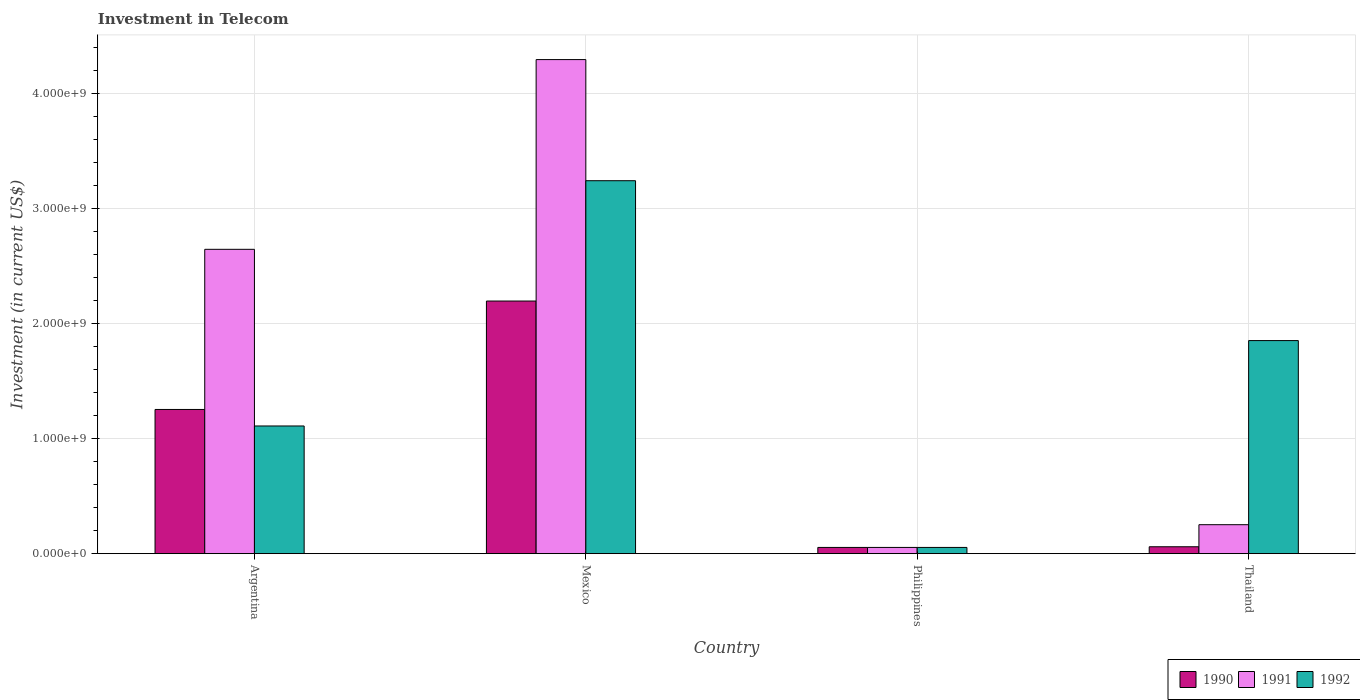How many groups of bars are there?
Ensure brevity in your answer.  4. Are the number of bars on each tick of the X-axis equal?
Provide a short and direct response. Yes. How many bars are there on the 1st tick from the left?
Your answer should be compact. 3. How many bars are there on the 2nd tick from the right?
Provide a short and direct response. 3. What is the amount invested in telecom in 1992 in Thailand?
Ensure brevity in your answer.  1.85e+09. Across all countries, what is the maximum amount invested in telecom in 1992?
Ensure brevity in your answer.  3.24e+09. Across all countries, what is the minimum amount invested in telecom in 1990?
Give a very brief answer. 5.42e+07. In which country was the amount invested in telecom in 1991 minimum?
Give a very brief answer. Philippines. What is the total amount invested in telecom in 1992 in the graph?
Offer a terse response. 6.26e+09. What is the difference between the amount invested in telecom in 1990 in Mexico and that in Thailand?
Provide a short and direct response. 2.14e+09. What is the difference between the amount invested in telecom in 1991 in Argentina and the amount invested in telecom in 1990 in Philippines?
Provide a short and direct response. 2.59e+09. What is the average amount invested in telecom in 1991 per country?
Offer a very short reply. 1.81e+09. What is the difference between the amount invested in telecom of/in 1990 and amount invested in telecom of/in 1991 in Mexico?
Make the answer very short. -2.10e+09. What is the ratio of the amount invested in telecom in 1992 in Mexico to that in Thailand?
Make the answer very short. 1.75. Is the amount invested in telecom in 1992 in Mexico less than that in Thailand?
Offer a very short reply. No. What is the difference between the highest and the second highest amount invested in telecom in 1991?
Provide a short and direct response. 1.65e+09. What is the difference between the highest and the lowest amount invested in telecom in 1991?
Make the answer very short. 4.24e+09. What does the 1st bar from the right in Argentina represents?
Your answer should be very brief. 1992. How many countries are there in the graph?
Provide a succinct answer. 4. What is the difference between two consecutive major ticks on the Y-axis?
Ensure brevity in your answer.  1.00e+09. Are the values on the major ticks of Y-axis written in scientific E-notation?
Offer a terse response. Yes. Does the graph contain grids?
Provide a short and direct response. Yes. How are the legend labels stacked?
Your response must be concise. Horizontal. What is the title of the graph?
Ensure brevity in your answer.  Investment in Telecom. Does "2013" appear as one of the legend labels in the graph?
Offer a terse response. No. What is the label or title of the X-axis?
Make the answer very short. Country. What is the label or title of the Y-axis?
Give a very brief answer. Investment (in current US$). What is the Investment (in current US$) of 1990 in Argentina?
Provide a short and direct response. 1.25e+09. What is the Investment (in current US$) in 1991 in Argentina?
Your response must be concise. 2.65e+09. What is the Investment (in current US$) of 1992 in Argentina?
Provide a succinct answer. 1.11e+09. What is the Investment (in current US$) of 1990 in Mexico?
Ensure brevity in your answer.  2.20e+09. What is the Investment (in current US$) in 1991 in Mexico?
Provide a short and direct response. 4.30e+09. What is the Investment (in current US$) of 1992 in Mexico?
Offer a very short reply. 3.24e+09. What is the Investment (in current US$) of 1990 in Philippines?
Make the answer very short. 5.42e+07. What is the Investment (in current US$) of 1991 in Philippines?
Give a very brief answer. 5.42e+07. What is the Investment (in current US$) of 1992 in Philippines?
Ensure brevity in your answer.  5.42e+07. What is the Investment (in current US$) in 1990 in Thailand?
Provide a short and direct response. 6.00e+07. What is the Investment (in current US$) in 1991 in Thailand?
Give a very brief answer. 2.52e+08. What is the Investment (in current US$) of 1992 in Thailand?
Ensure brevity in your answer.  1.85e+09. Across all countries, what is the maximum Investment (in current US$) in 1990?
Provide a succinct answer. 2.20e+09. Across all countries, what is the maximum Investment (in current US$) in 1991?
Provide a short and direct response. 4.30e+09. Across all countries, what is the maximum Investment (in current US$) of 1992?
Your answer should be compact. 3.24e+09. Across all countries, what is the minimum Investment (in current US$) in 1990?
Keep it short and to the point. 5.42e+07. Across all countries, what is the minimum Investment (in current US$) of 1991?
Make the answer very short. 5.42e+07. Across all countries, what is the minimum Investment (in current US$) of 1992?
Offer a terse response. 5.42e+07. What is the total Investment (in current US$) in 1990 in the graph?
Your response must be concise. 3.57e+09. What is the total Investment (in current US$) of 1991 in the graph?
Give a very brief answer. 7.25e+09. What is the total Investment (in current US$) of 1992 in the graph?
Ensure brevity in your answer.  6.26e+09. What is the difference between the Investment (in current US$) in 1990 in Argentina and that in Mexico?
Your answer should be very brief. -9.43e+08. What is the difference between the Investment (in current US$) in 1991 in Argentina and that in Mexico?
Offer a very short reply. -1.65e+09. What is the difference between the Investment (in current US$) in 1992 in Argentina and that in Mexico?
Keep it short and to the point. -2.13e+09. What is the difference between the Investment (in current US$) of 1990 in Argentina and that in Philippines?
Provide a succinct answer. 1.20e+09. What is the difference between the Investment (in current US$) of 1991 in Argentina and that in Philippines?
Ensure brevity in your answer.  2.59e+09. What is the difference between the Investment (in current US$) in 1992 in Argentina and that in Philippines?
Your answer should be compact. 1.06e+09. What is the difference between the Investment (in current US$) in 1990 in Argentina and that in Thailand?
Your answer should be compact. 1.19e+09. What is the difference between the Investment (in current US$) of 1991 in Argentina and that in Thailand?
Keep it short and to the point. 2.40e+09. What is the difference between the Investment (in current US$) in 1992 in Argentina and that in Thailand?
Your answer should be very brief. -7.43e+08. What is the difference between the Investment (in current US$) of 1990 in Mexico and that in Philippines?
Ensure brevity in your answer.  2.14e+09. What is the difference between the Investment (in current US$) of 1991 in Mexico and that in Philippines?
Offer a terse response. 4.24e+09. What is the difference between the Investment (in current US$) in 1992 in Mexico and that in Philippines?
Keep it short and to the point. 3.19e+09. What is the difference between the Investment (in current US$) of 1990 in Mexico and that in Thailand?
Keep it short and to the point. 2.14e+09. What is the difference between the Investment (in current US$) of 1991 in Mexico and that in Thailand?
Offer a terse response. 4.05e+09. What is the difference between the Investment (in current US$) in 1992 in Mexico and that in Thailand?
Provide a short and direct response. 1.39e+09. What is the difference between the Investment (in current US$) of 1990 in Philippines and that in Thailand?
Your response must be concise. -5.80e+06. What is the difference between the Investment (in current US$) of 1991 in Philippines and that in Thailand?
Provide a short and direct response. -1.98e+08. What is the difference between the Investment (in current US$) in 1992 in Philippines and that in Thailand?
Give a very brief answer. -1.80e+09. What is the difference between the Investment (in current US$) of 1990 in Argentina and the Investment (in current US$) of 1991 in Mexico?
Give a very brief answer. -3.04e+09. What is the difference between the Investment (in current US$) of 1990 in Argentina and the Investment (in current US$) of 1992 in Mexico?
Your response must be concise. -1.99e+09. What is the difference between the Investment (in current US$) of 1991 in Argentina and the Investment (in current US$) of 1992 in Mexico?
Your response must be concise. -5.97e+08. What is the difference between the Investment (in current US$) in 1990 in Argentina and the Investment (in current US$) in 1991 in Philippines?
Your answer should be compact. 1.20e+09. What is the difference between the Investment (in current US$) in 1990 in Argentina and the Investment (in current US$) in 1992 in Philippines?
Keep it short and to the point. 1.20e+09. What is the difference between the Investment (in current US$) of 1991 in Argentina and the Investment (in current US$) of 1992 in Philippines?
Give a very brief answer. 2.59e+09. What is the difference between the Investment (in current US$) of 1990 in Argentina and the Investment (in current US$) of 1991 in Thailand?
Offer a terse response. 1.00e+09. What is the difference between the Investment (in current US$) in 1990 in Argentina and the Investment (in current US$) in 1992 in Thailand?
Ensure brevity in your answer.  -5.99e+08. What is the difference between the Investment (in current US$) in 1991 in Argentina and the Investment (in current US$) in 1992 in Thailand?
Your answer should be very brief. 7.94e+08. What is the difference between the Investment (in current US$) in 1990 in Mexico and the Investment (in current US$) in 1991 in Philippines?
Give a very brief answer. 2.14e+09. What is the difference between the Investment (in current US$) in 1990 in Mexico and the Investment (in current US$) in 1992 in Philippines?
Offer a very short reply. 2.14e+09. What is the difference between the Investment (in current US$) in 1991 in Mexico and the Investment (in current US$) in 1992 in Philippines?
Provide a short and direct response. 4.24e+09. What is the difference between the Investment (in current US$) of 1990 in Mexico and the Investment (in current US$) of 1991 in Thailand?
Your answer should be compact. 1.95e+09. What is the difference between the Investment (in current US$) in 1990 in Mexico and the Investment (in current US$) in 1992 in Thailand?
Offer a very short reply. 3.44e+08. What is the difference between the Investment (in current US$) in 1991 in Mexico and the Investment (in current US$) in 1992 in Thailand?
Offer a terse response. 2.44e+09. What is the difference between the Investment (in current US$) of 1990 in Philippines and the Investment (in current US$) of 1991 in Thailand?
Your response must be concise. -1.98e+08. What is the difference between the Investment (in current US$) in 1990 in Philippines and the Investment (in current US$) in 1992 in Thailand?
Provide a short and direct response. -1.80e+09. What is the difference between the Investment (in current US$) of 1991 in Philippines and the Investment (in current US$) of 1992 in Thailand?
Your response must be concise. -1.80e+09. What is the average Investment (in current US$) of 1990 per country?
Ensure brevity in your answer.  8.92e+08. What is the average Investment (in current US$) in 1991 per country?
Make the answer very short. 1.81e+09. What is the average Investment (in current US$) of 1992 per country?
Offer a very short reply. 1.57e+09. What is the difference between the Investment (in current US$) in 1990 and Investment (in current US$) in 1991 in Argentina?
Your answer should be very brief. -1.39e+09. What is the difference between the Investment (in current US$) in 1990 and Investment (in current US$) in 1992 in Argentina?
Your answer should be very brief. 1.44e+08. What is the difference between the Investment (in current US$) of 1991 and Investment (in current US$) of 1992 in Argentina?
Give a very brief answer. 1.54e+09. What is the difference between the Investment (in current US$) of 1990 and Investment (in current US$) of 1991 in Mexico?
Keep it short and to the point. -2.10e+09. What is the difference between the Investment (in current US$) of 1990 and Investment (in current US$) of 1992 in Mexico?
Offer a very short reply. -1.05e+09. What is the difference between the Investment (in current US$) in 1991 and Investment (in current US$) in 1992 in Mexico?
Keep it short and to the point. 1.05e+09. What is the difference between the Investment (in current US$) in 1990 and Investment (in current US$) in 1992 in Philippines?
Ensure brevity in your answer.  0. What is the difference between the Investment (in current US$) in 1991 and Investment (in current US$) in 1992 in Philippines?
Your answer should be compact. 0. What is the difference between the Investment (in current US$) in 1990 and Investment (in current US$) in 1991 in Thailand?
Give a very brief answer. -1.92e+08. What is the difference between the Investment (in current US$) of 1990 and Investment (in current US$) of 1992 in Thailand?
Offer a terse response. -1.79e+09. What is the difference between the Investment (in current US$) of 1991 and Investment (in current US$) of 1992 in Thailand?
Your answer should be compact. -1.60e+09. What is the ratio of the Investment (in current US$) of 1990 in Argentina to that in Mexico?
Keep it short and to the point. 0.57. What is the ratio of the Investment (in current US$) of 1991 in Argentina to that in Mexico?
Provide a succinct answer. 0.62. What is the ratio of the Investment (in current US$) of 1992 in Argentina to that in Mexico?
Provide a short and direct response. 0.34. What is the ratio of the Investment (in current US$) in 1990 in Argentina to that in Philippines?
Make the answer very short. 23.15. What is the ratio of the Investment (in current US$) of 1991 in Argentina to that in Philippines?
Your response must be concise. 48.86. What is the ratio of the Investment (in current US$) in 1992 in Argentina to that in Philippines?
Make the answer very short. 20.5. What is the ratio of the Investment (in current US$) in 1990 in Argentina to that in Thailand?
Your answer should be compact. 20.91. What is the ratio of the Investment (in current US$) of 1991 in Argentina to that in Thailand?
Offer a terse response. 10.51. What is the ratio of the Investment (in current US$) of 1992 in Argentina to that in Thailand?
Your response must be concise. 0.6. What is the ratio of the Investment (in current US$) in 1990 in Mexico to that in Philippines?
Ensure brevity in your answer.  40.55. What is the ratio of the Investment (in current US$) of 1991 in Mexico to that in Philippines?
Ensure brevity in your answer.  79.32. What is the ratio of the Investment (in current US$) of 1992 in Mexico to that in Philippines?
Offer a very short reply. 59.87. What is the ratio of the Investment (in current US$) in 1990 in Mexico to that in Thailand?
Provide a succinct answer. 36.63. What is the ratio of the Investment (in current US$) in 1991 in Mexico to that in Thailand?
Your answer should be very brief. 17.06. What is the ratio of the Investment (in current US$) in 1992 in Mexico to that in Thailand?
Provide a succinct answer. 1.75. What is the ratio of the Investment (in current US$) of 1990 in Philippines to that in Thailand?
Offer a terse response. 0.9. What is the ratio of the Investment (in current US$) of 1991 in Philippines to that in Thailand?
Your response must be concise. 0.22. What is the ratio of the Investment (in current US$) of 1992 in Philippines to that in Thailand?
Make the answer very short. 0.03. What is the difference between the highest and the second highest Investment (in current US$) in 1990?
Offer a very short reply. 9.43e+08. What is the difference between the highest and the second highest Investment (in current US$) of 1991?
Your answer should be compact. 1.65e+09. What is the difference between the highest and the second highest Investment (in current US$) in 1992?
Offer a terse response. 1.39e+09. What is the difference between the highest and the lowest Investment (in current US$) in 1990?
Make the answer very short. 2.14e+09. What is the difference between the highest and the lowest Investment (in current US$) in 1991?
Your answer should be very brief. 4.24e+09. What is the difference between the highest and the lowest Investment (in current US$) of 1992?
Keep it short and to the point. 3.19e+09. 